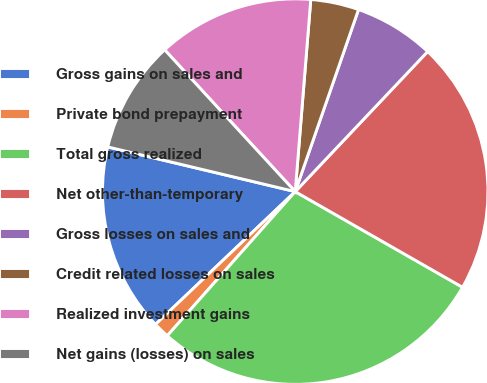<chart> <loc_0><loc_0><loc_500><loc_500><pie_chart><fcel>Gross gains on sales and<fcel>Private bond prepayment<fcel>Total gross realized<fcel>Net other-than-temporary<fcel>Gross losses on sales and<fcel>Credit related losses on sales<fcel>Realized investment gains<fcel>Net gains (losses) on sales<nl><fcel>15.82%<fcel>1.35%<fcel>28.29%<fcel>21.21%<fcel>6.73%<fcel>4.04%<fcel>13.13%<fcel>9.43%<nl></chart> 